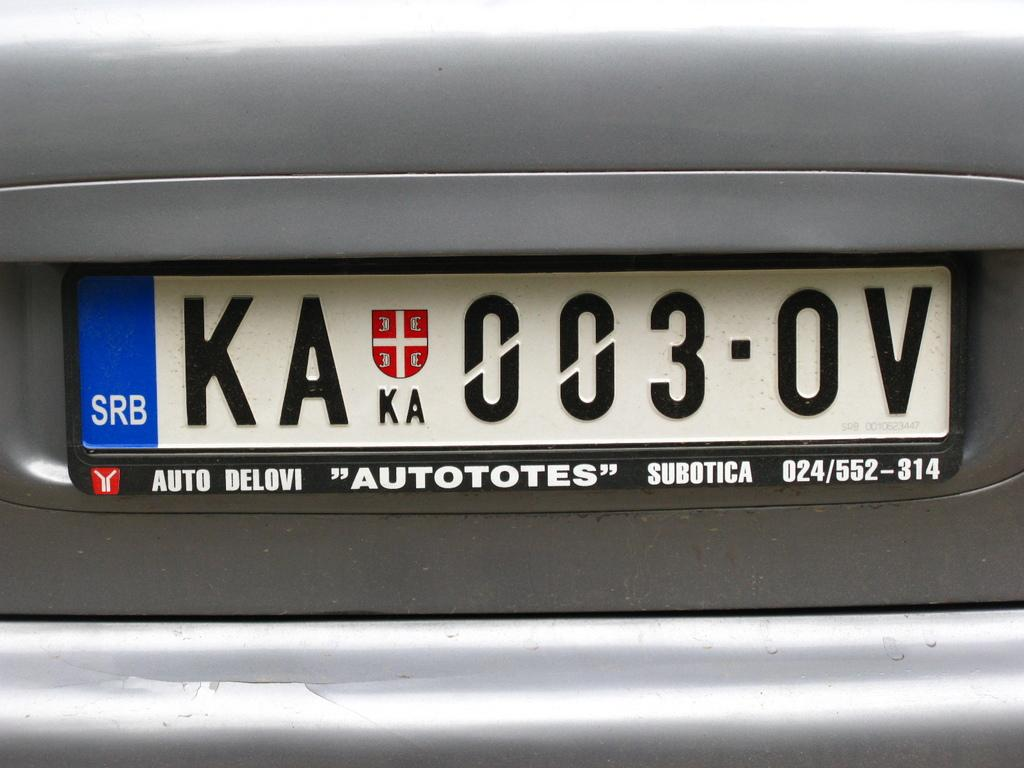<image>
Offer a succinct explanation of the picture presented. A silver car with a license plate reading KA 003 0V 